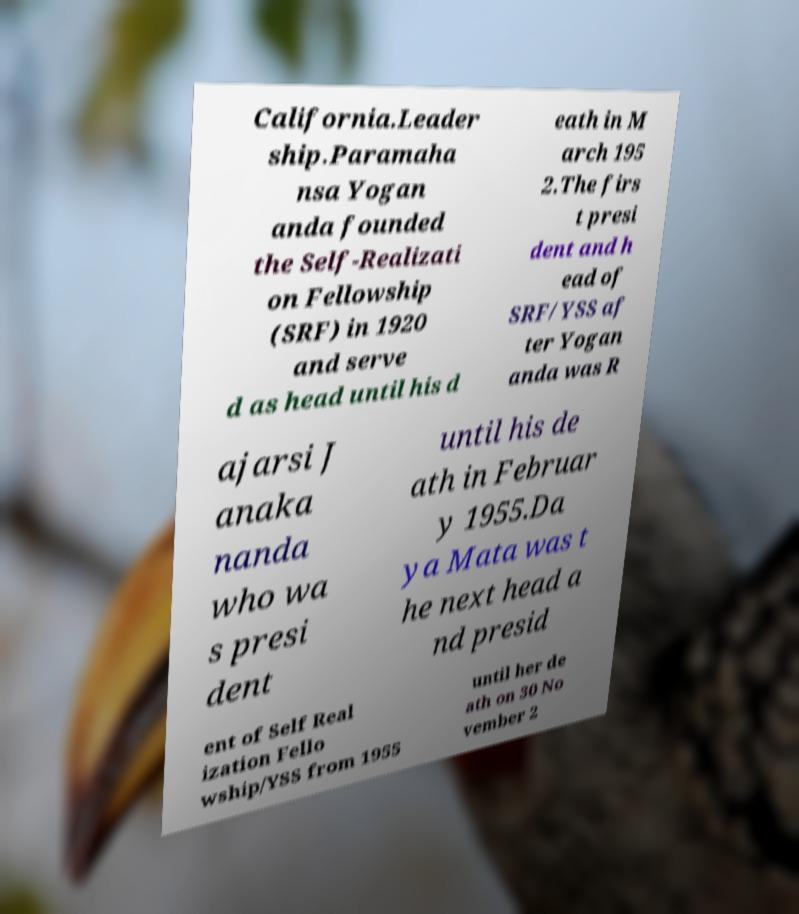What messages or text are displayed in this image? I need them in a readable, typed format. California.Leader ship.Paramaha nsa Yogan anda founded the Self-Realizati on Fellowship (SRF) in 1920 and serve d as head until his d eath in M arch 195 2.The firs t presi dent and h ead of SRF/YSS af ter Yogan anda was R ajarsi J anaka nanda who wa s presi dent until his de ath in Februar y 1955.Da ya Mata was t he next head a nd presid ent of Self Real ization Fello wship/YSS from 1955 until her de ath on 30 No vember 2 